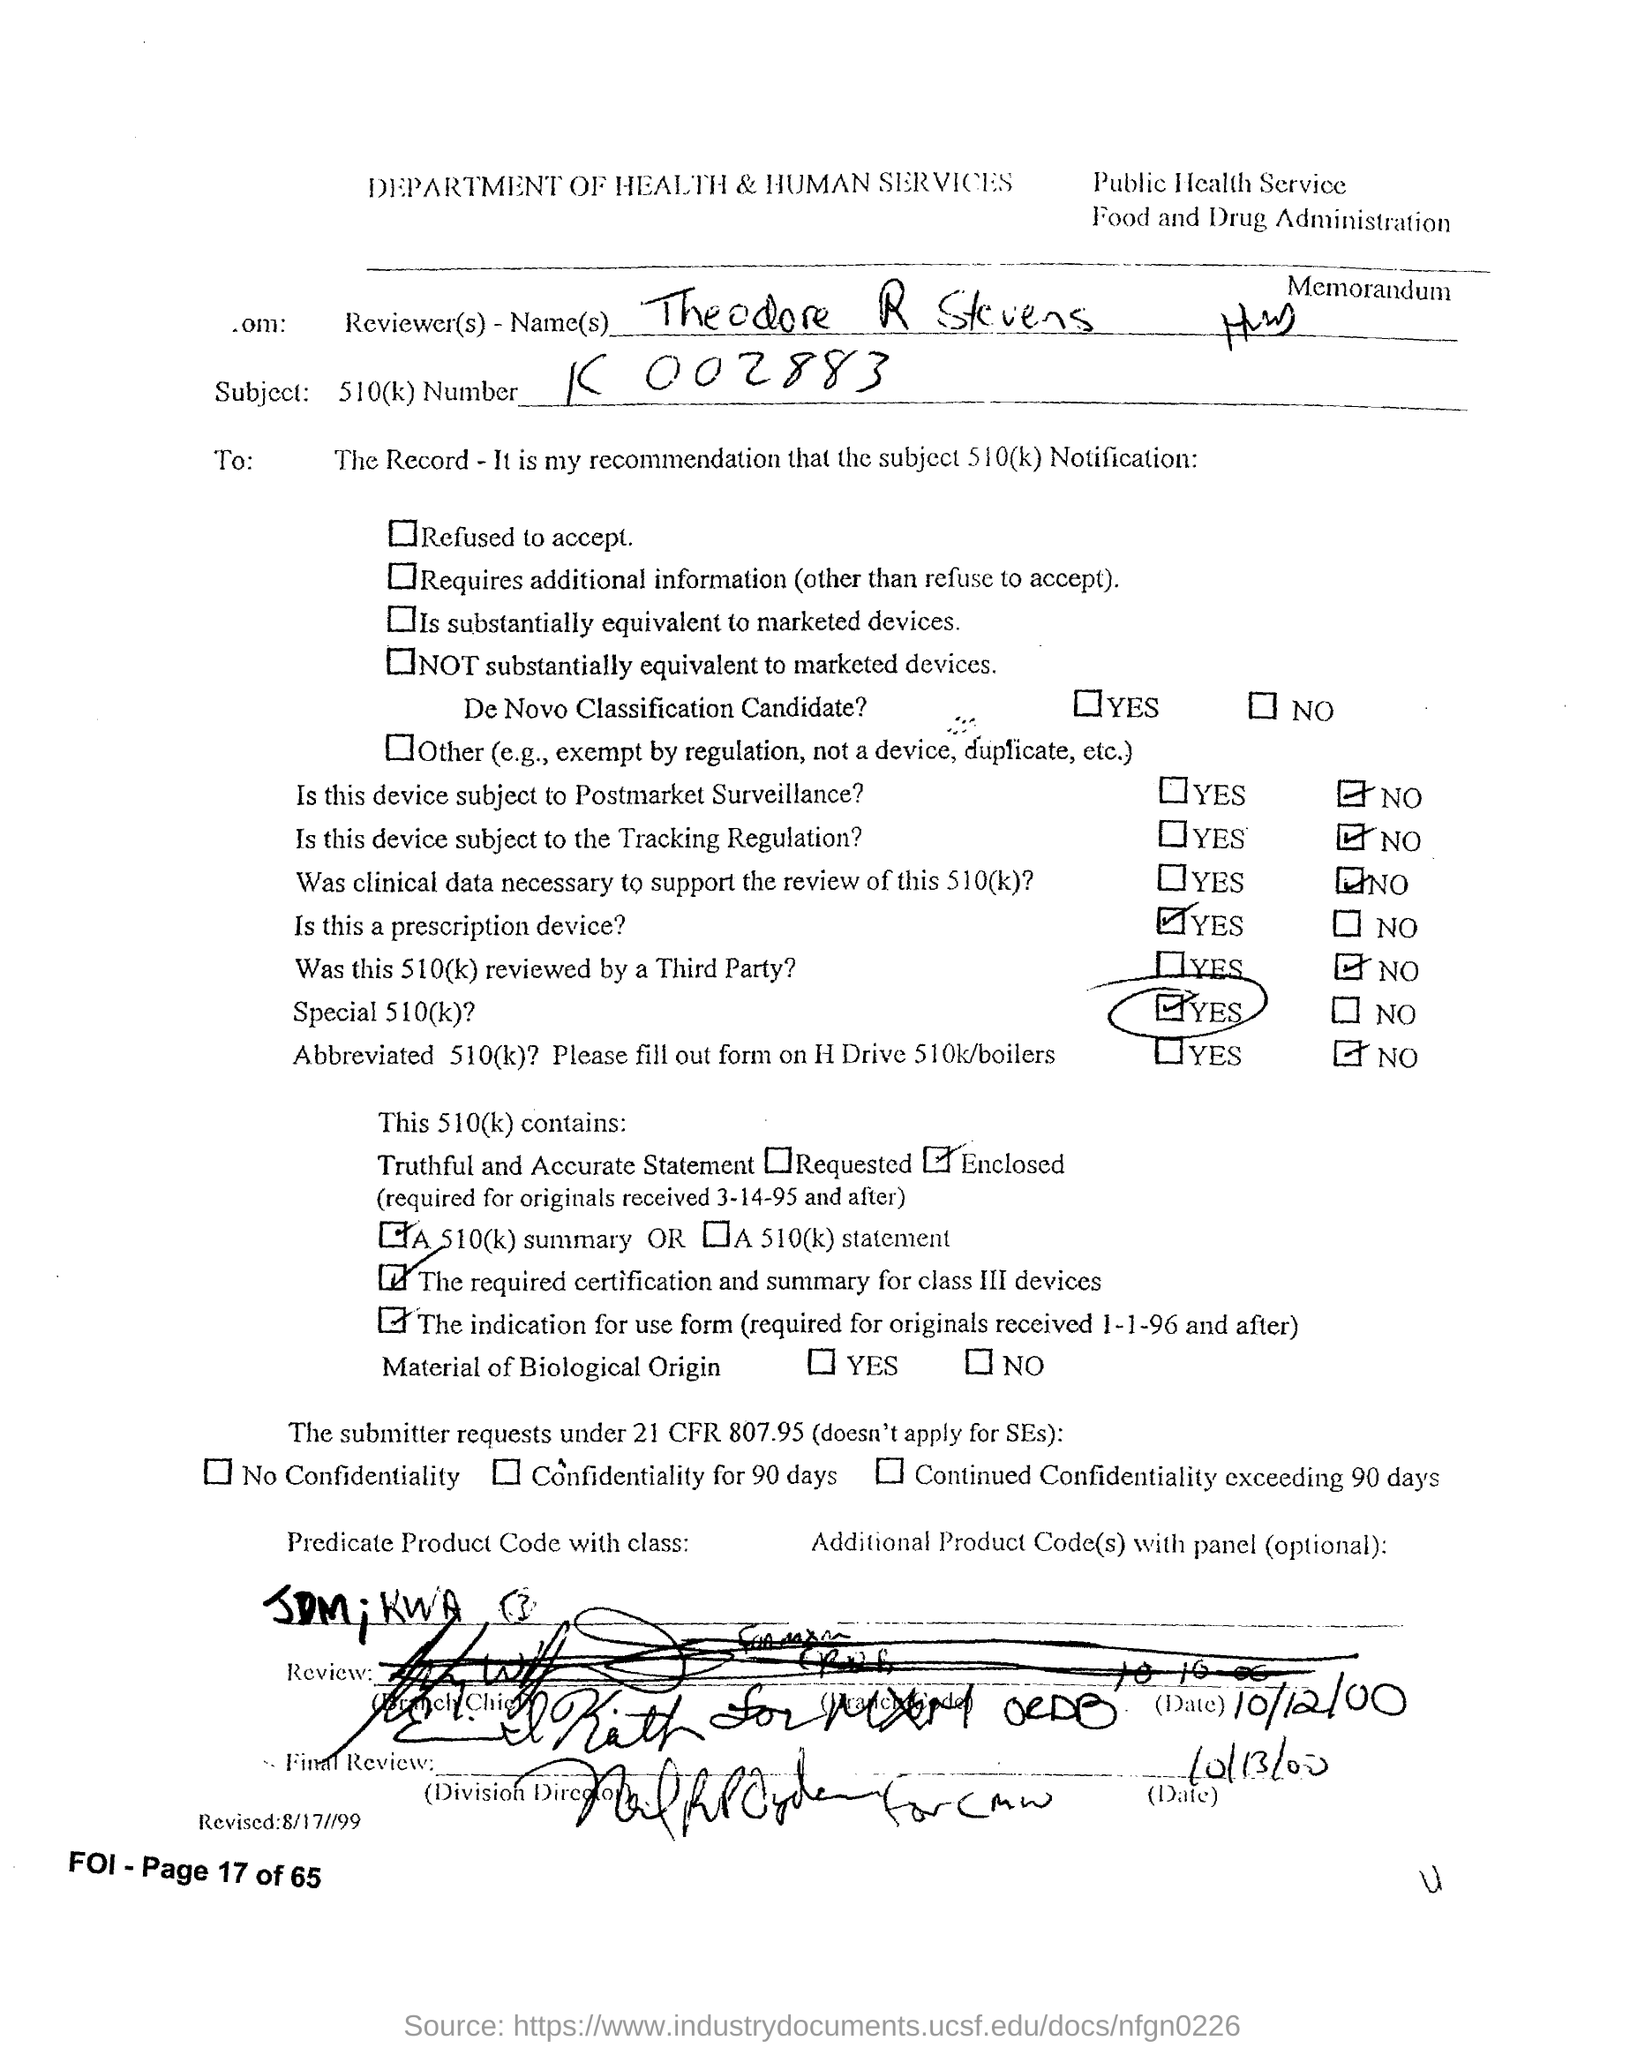Point out several critical features in this image. The header of the document indicates that the Department of Health & Human Services is mentioned. 